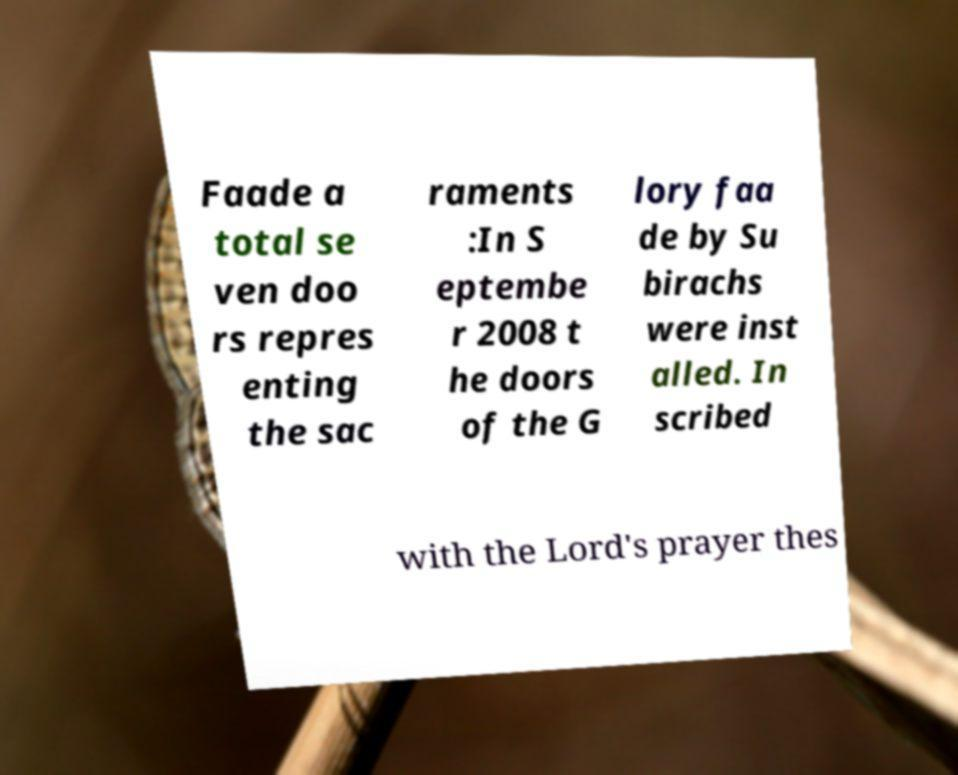There's text embedded in this image that I need extracted. Can you transcribe it verbatim? Faade a total se ven doo rs repres enting the sac raments :In S eptembe r 2008 t he doors of the G lory faa de by Su birachs were inst alled. In scribed with the Lord's prayer thes 